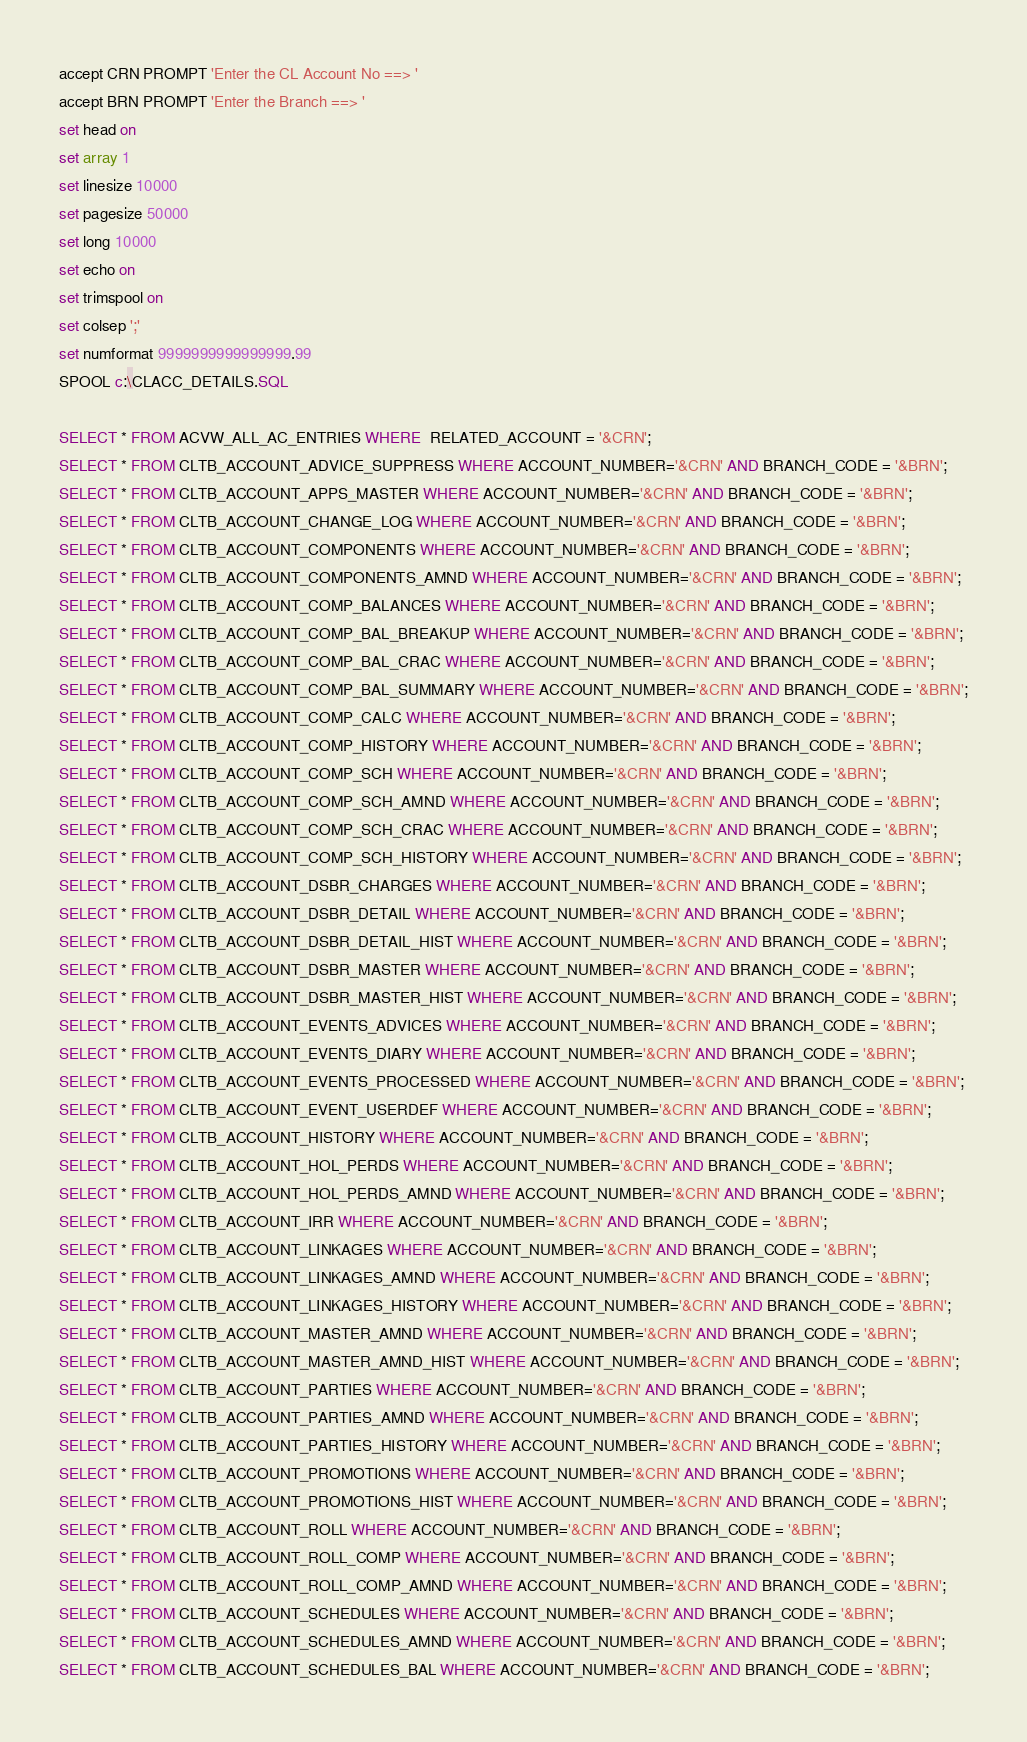<code> <loc_0><loc_0><loc_500><loc_500><_SQL_>accept CRN PROMPT 'Enter the CL Account No ==> '
accept BRN PROMPT 'Enter the Branch ==> '
set head on
set array 1
set linesize 10000
set pagesize 50000
set long 10000
set echo on
set trimspool on
set colsep ';'
set numformat 9999999999999999.99
SPOOL c:\CLACC_DETAILS.SQL

SELECT * FROM ACVW_ALL_AC_ENTRIES WHERE  RELATED_ACCOUNT = '&CRN';
SELECT * FROM CLTB_ACCOUNT_ADVICE_SUPPRESS WHERE ACCOUNT_NUMBER='&CRN' AND BRANCH_CODE = '&BRN';
SELECT * FROM CLTB_ACCOUNT_APPS_MASTER WHERE ACCOUNT_NUMBER='&CRN' AND BRANCH_CODE = '&BRN';
SELECT * FROM CLTB_ACCOUNT_CHANGE_LOG WHERE ACCOUNT_NUMBER='&CRN' AND BRANCH_CODE = '&BRN';
SELECT * FROM CLTB_ACCOUNT_COMPONENTS WHERE ACCOUNT_NUMBER='&CRN' AND BRANCH_CODE = '&BRN';
SELECT * FROM CLTB_ACCOUNT_COMPONENTS_AMND WHERE ACCOUNT_NUMBER='&CRN' AND BRANCH_CODE = '&BRN';
SELECT * FROM CLTB_ACCOUNT_COMP_BALANCES WHERE ACCOUNT_NUMBER='&CRN' AND BRANCH_CODE = '&BRN';
SELECT * FROM CLTB_ACCOUNT_COMP_BAL_BREAKUP WHERE ACCOUNT_NUMBER='&CRN' AND BRANCH_CODE = '&BRN';
SELECT * FROM CLTB_ACCOUNT_COMP_BAL_CRAC WHERE ACCOUNT_NUMBER='&CRN' AND BRANCH_CODE = '&BRN';
SELECT * FROM CLTB_ACCOUNT_COMP_BAL_SUMMARY WHERE ACCOUNT_NUMBER='&CRN' AND BRANCH_CODE = '&BRN';
SELECT * FROM CLTB_ACCOUNT_COMP_CALC WHERE ACCOUNT_NUMBER='&CRN' AND BRANCH_CODE = '&BRN';
SELECT * FROM CLTB_ACCOUNT_COMP_HISTORY WHERE ACCOUNT_NUMBER='&CRN' AND BRANCH_CODE = '&BRN';
SELECT * FROM CLTB_ACCOUNT_COMP_SCH WHERE ACCOUNT_NUMBER='&CRN' AND BRANCH_CODE = '&BRN';
SELECT * FROM CLTB_ACCOUNT_COMP_SCH_AMND WHERE ACCOUNT_NUMBER='&CRN' AND BRANCH_CODE = '&BRN';
SELECT * FROM CLTB_ACCOUNT_COMP_SCH_CRAC WHERE ACCOUNT_NUMBER='&CRN' AND BRANCH_CODE = '&BRN';
SELECT * FROM CLTB_ACCOUNT_COMP_SCH_HISTORY WHERE ACCOUNT_NUMBER='&CRN' AND BRANCH_CODE = '&BRN';
SELECT * FROM CLTB_ACCOUNT_DSBR_CHARGES WHERE ACCOUNT_NUMBER='&CRN' AND BRANCH_CODE = '&BRN';
SELECT * FROM CLTB_ACCOUNT_DSBR_DETAIL WHERE ACCOUNT_NUMBER='&CRN' AND BRANCH_CODE = '&BRN';
SELECT * FROM CLTB_ACCOUNT_DSBR_DETAIL_HIST WHERE ACCOUNT_NUMBER='&CRN' AND BRANCH_CODE = '&BRN';
SELECT * FROM CLTB_ACCOUNT_DSBR_MASTER WHERE ACCOUNT_NUMBER='&CRN' AND BRANCH_CODE = '&BRN';
SELECT * FROM CLTB_ACCOUNT_DSBR_MASTER_HIST WHERE ACCOUNT_NUMBER='&CRN' AND BRANCH_CODE = '&BRN';
SELECT * FROM CLTB_ACCOUNT_EVENTS_ADVICES WHERE ACCOUNT_NUMBER='&CRN' AND BRANCH_CODE = '&BRN';
SELECT * FROM CLTB_ACCOUNT_EVENTS_DIARY WHERE ACCOUNT_NUMBER='&CRN' AND BRANCH_CODE = '&BRN';
SELECT * FROM CLTB_ACCOUNT_EVENTS_PROCESSED WHERE ACCOUNT_NUMBER='&CRN' AND BRANCH_CODE = '&BRN';
SELECT * FROM CLTB_ACCOUNT_EVENT_USERDEF WHERE ACCOUNT_NUMBER='&CRN' AND BRANCH_CODE = '&BRN';
SELECT * FROM CLTB_ACCOUNT_HISTORY WHERE ACCOUNT_NUMBER='&CRN' AND BRANCH_CODE = '&BRN';
SELECT * FROM CLTB_ACCOUNT_HOL_PERDS WHERE ACCOUNT_NUMBER='&CRN' AND BRANCH_CODE = '&BRN';
SELECT * FROM CLTB_ACCOUNT_HOL_PERDS_AMND WHERE ACCOUNT_NUMBER='&CRN' AND BRANCH_CODE = '&BRN';
SELECT * FROM CLTB_ACCOUNT_IRR WHERE ACCOUNT_NUMBER='&CRN' AND BRANCH_CODE = '&BRN';
SELECT * FROM CLTB_ACCOUNT_LINKAGES WHERE ACCOUNT_NUMBER='&CRN' AND BRANCH_CODE = '&BRN';
SELECT * FROM CLTB_ACCOUNT_LINKAGES_AMND WHERE ACCOUNT_NUMBER='&CRN' AND BRANCH_CODE = '&BRN';
SELECT * FROM CLTB_ACCOUNT_LINKAGES_HISTORY WHERE ACCOUNT_NUMBER='&CRN' AND BRANCH_CODE = '&BRN';
SELECT * FROM CLTB_ACCOUNT_MASTER_AMND WHERE ACCOUNT_NUMBER='&CRN' AND BRANCH_CODE = '&BRN';
SELECT * FROM CLTB_ACCOUNT_MASTER_AMND_HIST WHERE ACCOUNT_NUMBER='&CRN' AND BRANCH_CODE = '&BRN';
SELECT * FROM CLTB_ACCOUNT_PARTIES WHERE ACCOUNT_NUMBER='&CRN' AND BRANCH_CODE = '&BRN';
SELECT * FROM CLTB_ACCOUNT_PARTIES_AMND WHERE ACCOUNT_NUMBER='&CRN' AND BRANCH_CODE = '&BRN';
SELECT * FROM CLTB_ACCOUNT_PARTIES_HISTORY WHERE ACCOUNT_NUMBER='&CRN' AND BRANCH_CODE = '&BRN';
SELECT * FROM CLTB_ACCOUNT_PROMOTIONS WHERE ACCOUNT_NUMBER='&CRN' AND BRANCH_CODE = '&BRN';
SELECT * FROM CLTB_ACCOUNT_PROMOTIONS_HIST WHERE ACCOUNT_NUMBER='&CRN' AND BRANCH_CODE = '&BRN';
SELECT * FROM CLTB_ACCOUNT_ROLL WHERE ACCOUNT_NUMBER='&CRN' AND BRANCH_CODE = '&BRN';
SELECT * FROM CLTB_ACCOUNT_ROLL_COMP WHERE ACCOUNT_NUMBER='&CRN' AND BRANCH_CODE = '&BRN';
SELECT * FROM CLTB_ACCOUNT_ROLL_COMP_AMND WHERE ACCOUNT_NUMBER='&CRN' AND BRANCH_CODE = '&BRN';
SELECT * FROM CLTB_ACCOUNT_SCHEDULES WHERE ACCOUNT_NUMBER='&CRN' AND BRANCH_CODE = '&BRN';
SELECT * FROM CLTB_ACCOUNT_SCHEDULES_AMND WHERE ACCOUNT_NUMBER='&CRN' AND BRANCH_CODE = '&BRN';
SELECT * FROM CLTB_ACCOUNT_SCHEDULES_BAL WHERE ACCOUNT_NUMBER='&CRN' AND BRANCH_CODE = '&BRN';</code> 